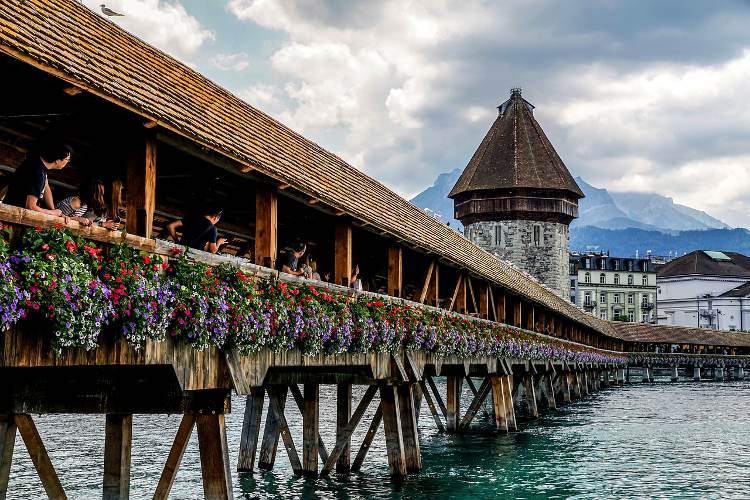Could you speculate on the artistic inspiration behind this bridge's design? The artistic inspiration behind the design of the Chapel Bridge seems to be deeply rooted in practicality and local tradition, merged with an appreciation for aesthetic beauty. On one side, the wooden structure and covered walkways demonstrate a practical approach to protect travelers from the elements, a necessity in medieval times. The addition of plentiful colorful flowers speaks to a love for nature and a desire to beautify public spaces, embodying a blend of functionality and artistic expression. The medieval paintings that adorn the interior of the bridge suggest an effort to infuse art into everyday life, turning a simple means of crossing into a gallery of historical storytelling. The design of the Water Tower, with its stalwart, sturdy construction, reflects the defensive needs of the period while standing as a timeless piece of craftsmanship. Together, these elements create a cohesive and charming work of art that has stood the test of time. 